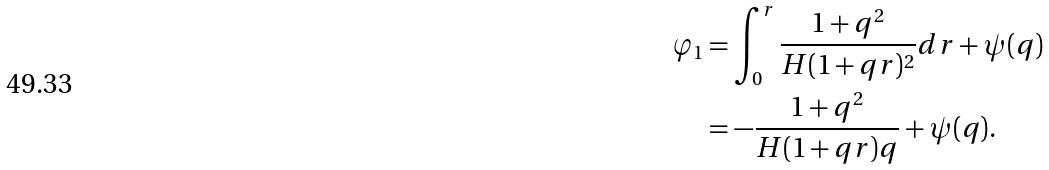<formula> <loc_0><loc_0><loc_500><loc_500>\varphi _ { 1 } & = \int _ { 0 } ^ { r } \frac { 1 + q ^ { 2 } } { H ( 1 + q r ) ^ { 2 } } d r + \psi ( q ) \\ & = - \frac { 1 + q ^ { 2 } } { H ( 1 + q r ) q } + \psi ( q ) .</formula> 